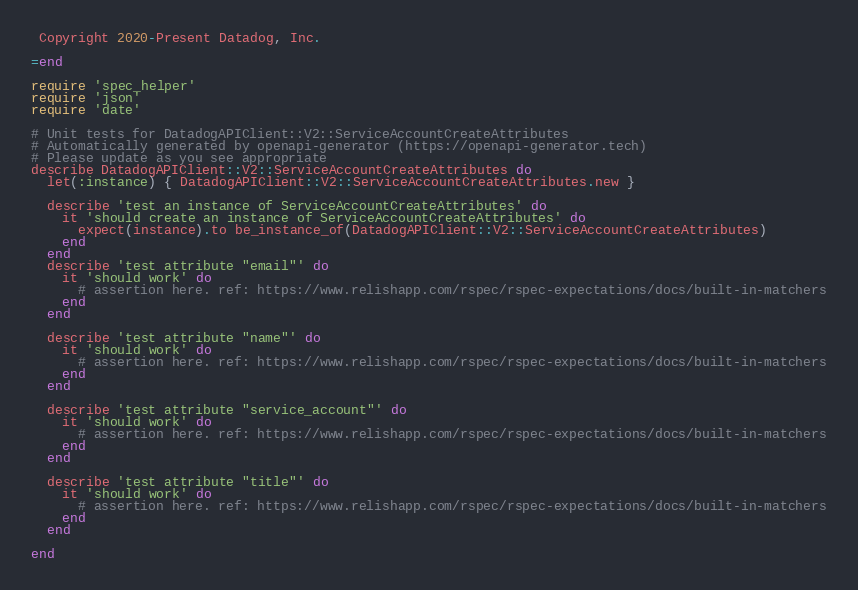<code> <loc_0><loc_0><loc_500><loc_500><_Ruby_> Copyright 2020-Present Datadog, Inc.

=end

require 'spec_helper'
require 'json'
require 'date'

# Unit tests for DatadogAPIClient::V2::ServiceAccountCreateAttributes
# Automatically generated by openapi-generator (https://openapi-generator.tech)
# Please update as you see appropriate
describe DatadogAPIClient::V2::ServiceAccountCreateAttributes do
  let(:instance) { DatadogAPIClient::V2::ServiceAccountCreateAttributes.new }

  describe 'test an instance of ServiceAccountCreateAttributes' do
    it 'should create an instance of ServiceAccountCreateAttributes' do
      expect(instance).to be_instance_of(DatadogAPIClient::V2::ServiceAccountCreateAttributes)
    end
  end
  describe 'test attribute "email"' do
    it 'should work' do
      # assertion here. ref: https://www.relishapp.com/rspec/rspec-expectations/docs/built-in-matchers
    end
  end

  describe 'test attribute "name"' do
    it 'should work' do
      # assertion here. ref: https://www.relishapp.com/rspec/rspec-expectations/docs/built-in-matchers
    end
  end

  describe 'test attribute "service_account"' do
    it 'should work' do
      # assertion here. ref: https://www.relishapp.com/rspec/rspec-expectations/docs/built-in-matchers
    end
  end

  describe 'test attribute "title"' do
    it 'should work' do
      # assertion here. ref: https://www.relishapp.com/rspec/rspec-expectations/docs/built-in-matchers
    end
  end

end
</code> 